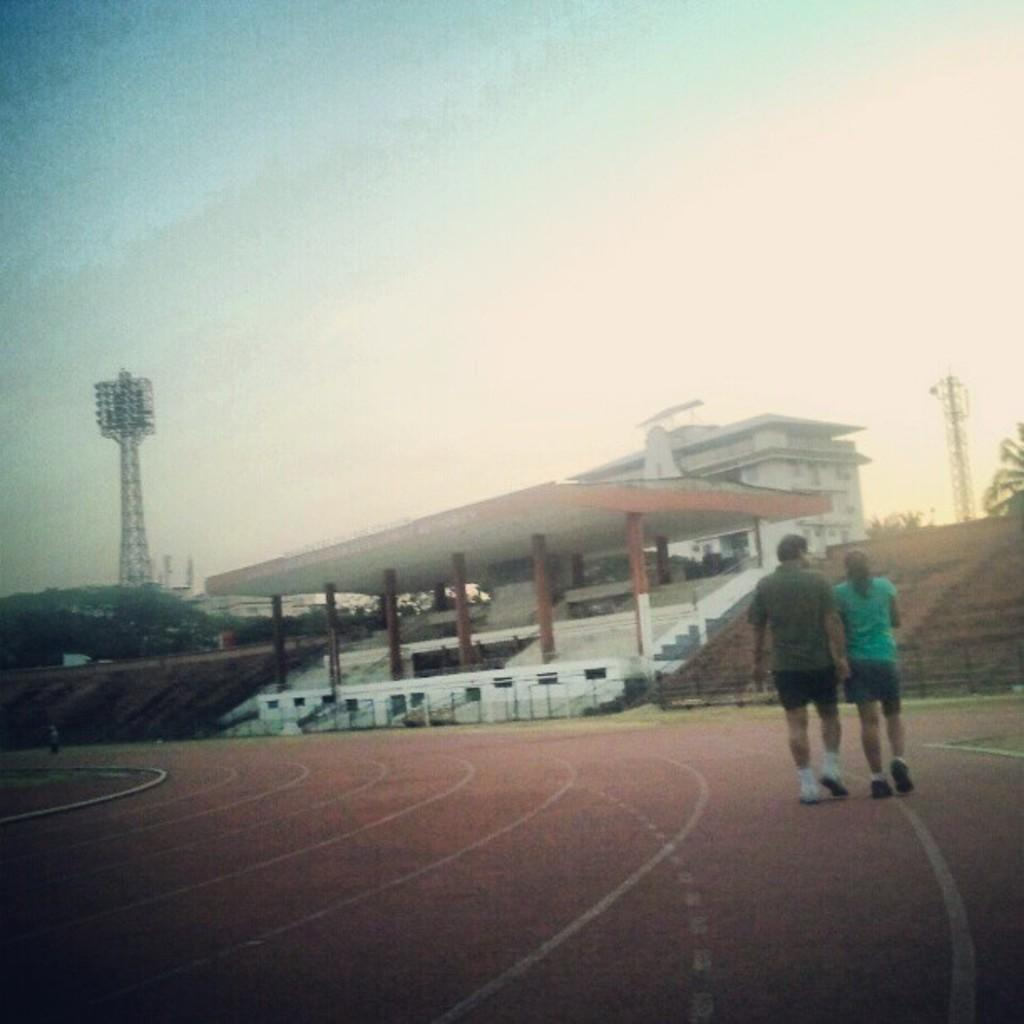Who can be seen in the image? There is a man and a woman in the image. What are the man and woman doing in the image? The man and woman are walking. What can be seen under the man and woman's feet in the image? The ground is visible in the image. What is visible in the distance behind the man and woman? There is a building, towers, and trees in the background of the image. What type of straw is being used by the man and woman to communicate in the image? There is no straw present in the image, and the man and woman are not using any object to communicate. 